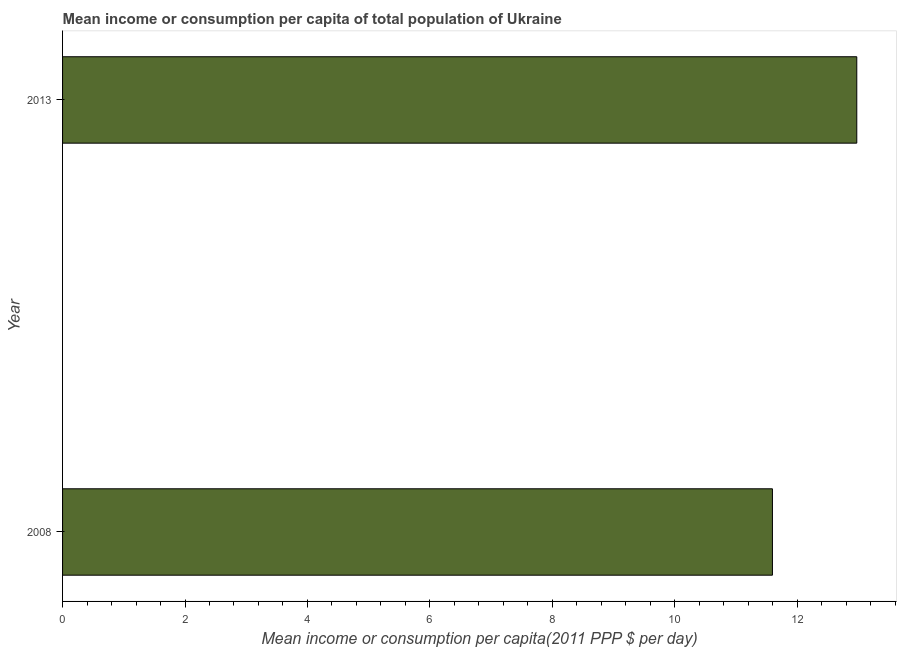What is the title of the graph?
Make the answer very short. Mean income or consumption per capita of total population of Ukraine. What is the label or title of the X-axis?
Offer a very short reply. Mean income or consumption per capita(2011 PPP $ per day). What is the mean income or consumption in 2013?
Give a very brief answer. 12.97. Across all years, what is the maximum mean income or consumption?
Make the answer very short. 12.97. Across all years, what is the minimum mean income or consumption?
Provide a succinct answer. 11.6. In which year was the mean income or consumption maximum?
Provide a short and direct response. 2013. In which year was the mean income or consumption minimum?
Give a very brief answer. 2008. What is the sum of the mean income or consumption?
Offer a very short reply. 24.57. What is the difference between the mean income or consumption in 2008 and 2013?
Give a very brief answer. -1.38. What is the average mean income or consumption per year?
Your response must be concise. 12.29. What is the median mean income or consumption?
Your answer should be compact. 12.29. In how many years, is the mean income or consumption greater than 4.4 $?
Provide a short and direct response. 2. What is the ratio of the mean income or consumption in 2008 to that in 2013?
Offer a terse response. 0.89. How many bars are there?
Provide a succinct answer. 2. Are all the bars in the graph horizontal?
Your answer should be very brief. Yes. What is the Mean income or consumption per capita(2011 PPP $ per day) of 2008?
Ensure brevity in your answer.  11.6. What is the Mean income or consumption per capita(2011 PPP $ per day) in 2013?
Make the answer very short. 12.97. What is the difference between the Mean income or consumption per capita(2011 PPP $ per day) in 2008 and 2013?
Ensure brevity in your answer.  -1.38. What is the ratio of the Mean income or consumption per capita(2011 PPP $ per day) in 2008 to that in 2013?
Give a very brief answer. 0.89. 